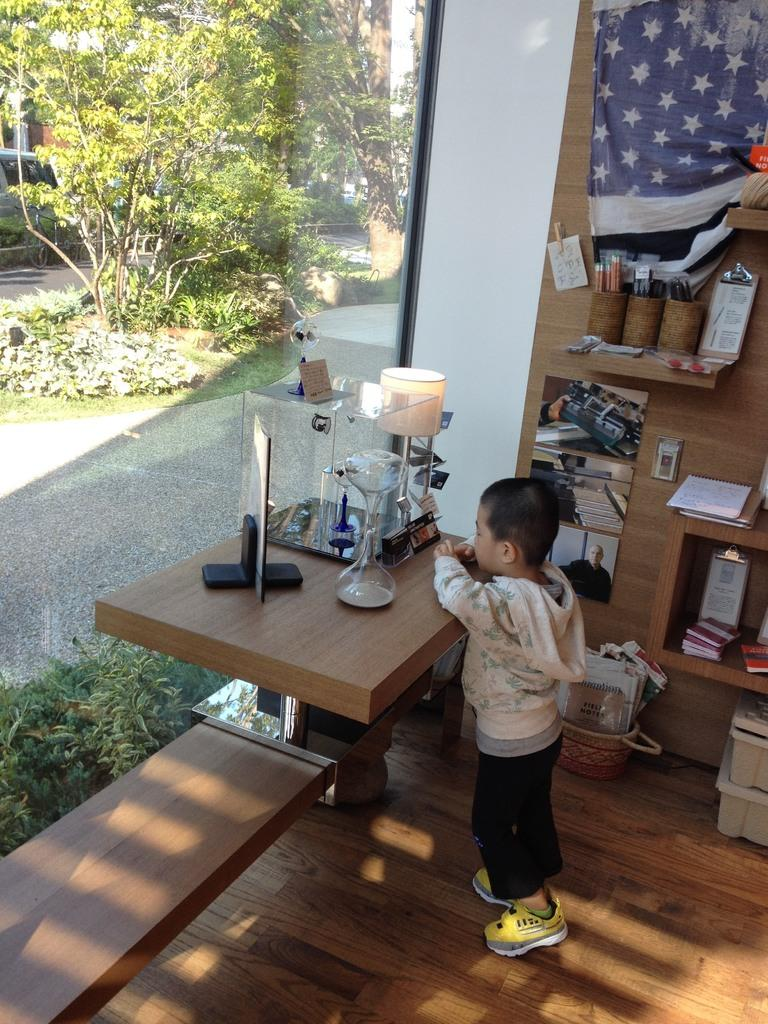What type of vegetation can be seen in the image? There are trees and plants in the image. What is the boy doing in the image? The boy is standing on the floor in the image. What color is the ink on the boy's shirt in the image? There is no ink or shirt mentioned in the image; the boy is simply standing on the floor. 